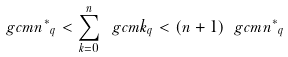Convert formula to latex. <formula><loc_0><loc_0><loc_500><loc_500>\ g c { m } { n ^ { * } } _ { q } < \sum _ { k = 0 } ^ { n } \ g c { m } { k } _ { q } < ( n + 1 ) \ g c { m } { n ^ { * } } _ { q }</formula> 